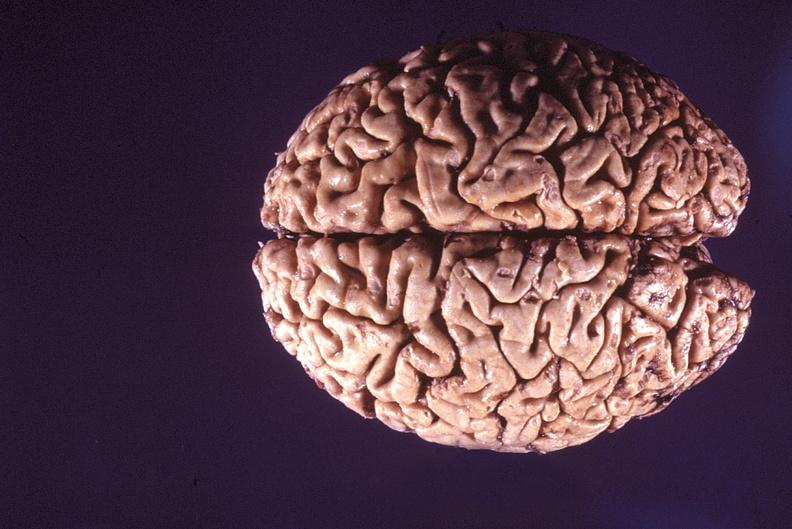s stress present?
Answer the question using a single word or phrase. No 